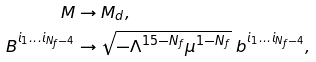Convert formula to latex. <formula><loc_0><loc_0><loc_500><loc_500>M & \to M _ { d } , \\ B ^ { i _ { 1 } \dots i _ { N _ { f } - 4 } } & \to \sqrt { - \Lambda ^ { 1 5 - N _ { f } } \mu ^ { 1 - N _ { f } } } \ b ^ { i _ { 1 } \dots i _ { N _ { f } - 4 } } ,</formula> 